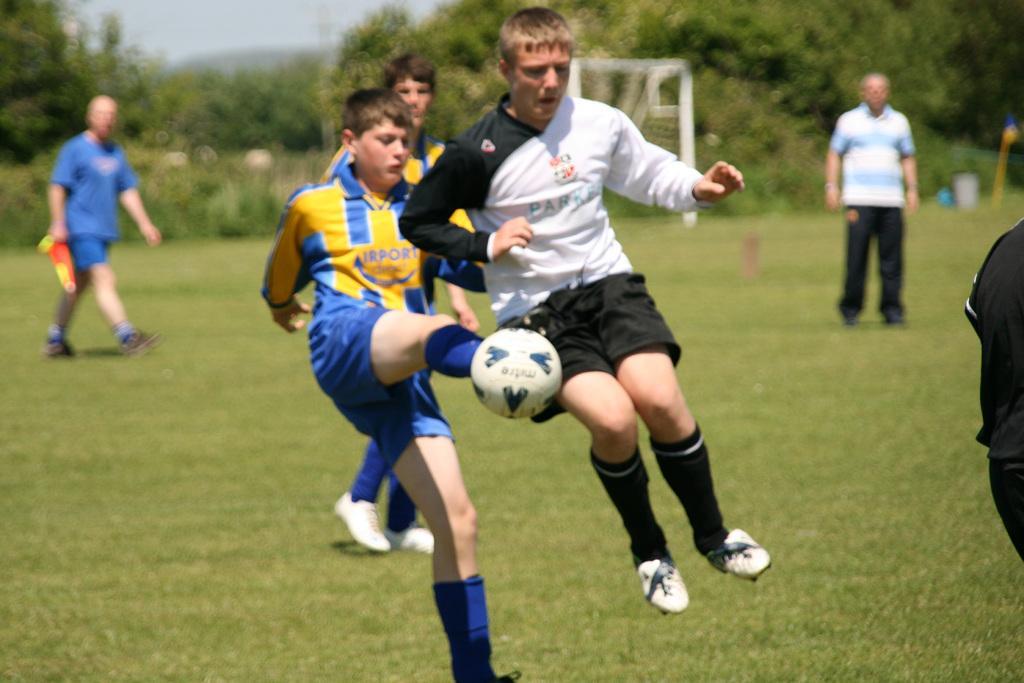In one or two sentences, can you explain what this image depicts? In the center we can see few players were holding ball. On the right we can see one person standing. In the background we can see trees,net and two persons were standing. 